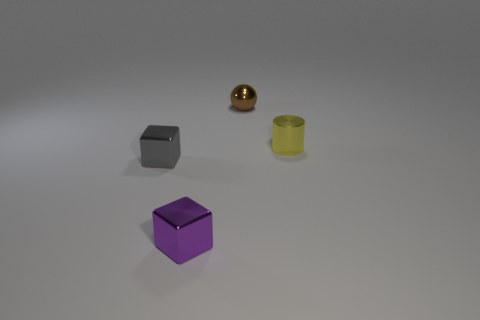What are the objects made of in this image? The objects appear to be 3D renderings with different materials. The cube in the front seems to have a matte surface, possibly representing plastic, while the small brown sphere and the cylinder on the right exhibit shiny surfaces, indicative of a metallic material. 